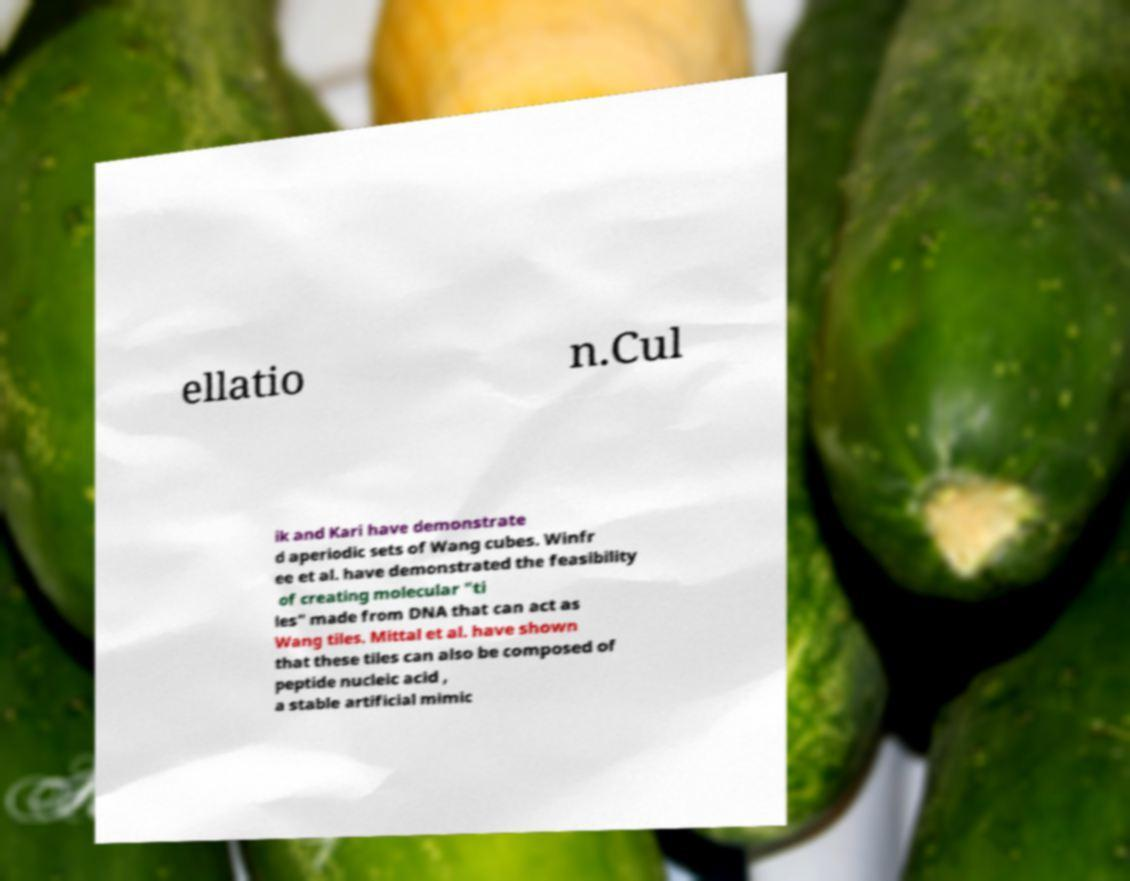Can you accurately transcribe the text from the provided image for me? ellatio n.Cul ik and Kari have demonstrate d aperiodic sets of Wang cubes. Winfr ee et al. have demonstrated the feasibility of creating molecular "ti les" made from DNA that can act as Wang tiles. Mittal et al. have shown that these tiles can also be composed of peptide nucleic acid , a stable artificial mimic 